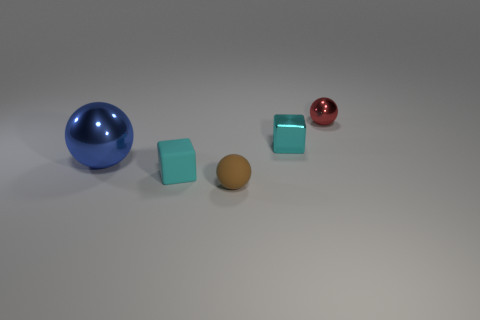How many other things are the same color as the big ball?
Offer a terse response. 0. How many shiny things are either small brown balls or big green balls?
Your answer should be compact. 0. There is a large object to the left of the brown rubber object; is its color the same as the tiny block that is on the right side of the tiny brown matte object?
Keep it short and to the point. No. Are there any other things that have the same material as the red thing?
Offer a very short reply. Yes. What is the size of the matte object that is the same shape as the tiny cyan metal thing?
Keep it short and to the point. Small. Are there more small rubber spheres that are on the left side of the small rubber cube than large red spheres?
Your response must be concise. No. Is the ball behind the blue metal ball made of the same material as the large blue ball?
Make the answer very short. Yes. What is the size of the brown rubber ball that is in front of the metal ball left of the metallic ball that is behind the big blue shiny sphere?
Make the answer very short. Small. There is a cube that is made of the same material as the brown thing; what is its size?
Offer a terse response. Small. What is the color of the sphere that is both right of the blue thing and left of the small metallic block?
Offer a very short reply. Brown. 